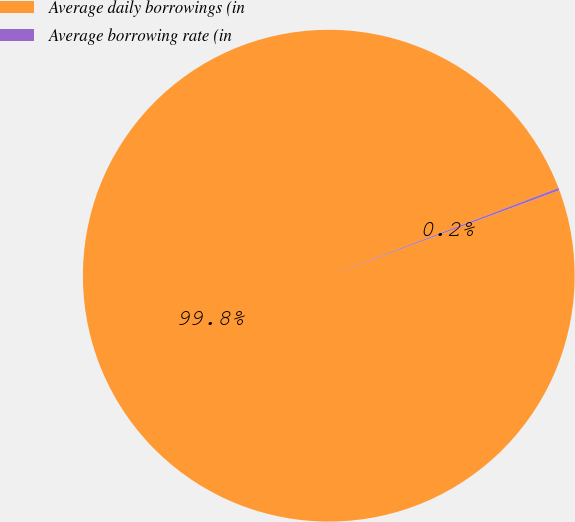<chart> <loc_0><loc_0><loc_500><loc_500><pie_chart><fcel>Average daily borrowings (in<fcel>Average borrowing rate (in<nl><fcel>99.85%<fcel>0.15%<nl></chart> 